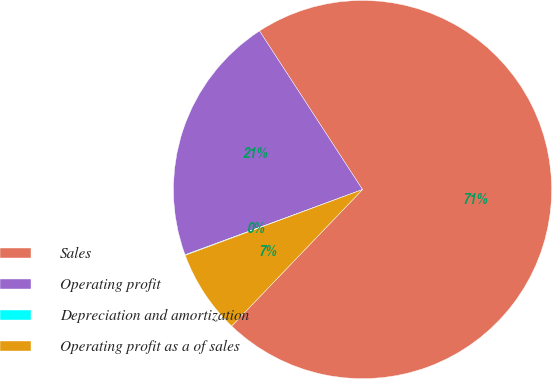<chart> <loc_0><loc_0><loc_500><loc_500><pie_chart><fcel>Sales<fcel>Operating profit<fcel>Depreciation and amortization<fcel>Operating profit as a of sales<nl><fcel>71.34%<fcel>21.44%<fcel>0.05%<fcel>7.18%<nl></chart> 